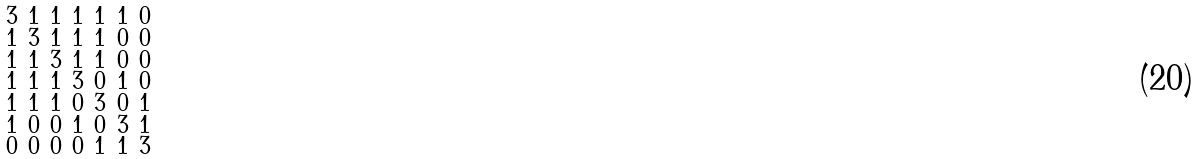Convert formula to latex. <formula><loc_0><loc_0><loc_500><loc_500>\begin{smallmatrix} 3 & 1 & 1 & 1 & 1 & 1 & 0 \\ 1 & 3 & 1 & 1 & 1 & 0 & 0 \\ 1 & 1 & 3 & 1 & 1 & 0 & 0 \\ 1 & 1 & 1 & 3 & 0 & 1 & 0 \\ 1 & 1 & 1 & 0 & 3 & 0 & 1 \\ 1 & 0 & 0 & 1 & 0 & 3 & 1 \\ 0 & 0 & 0 & 0 & 1 & 1 & 3 \end{smallmatrix}</formula> 